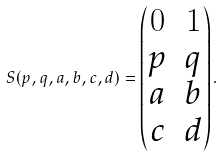Convert formula to latex. <formula><loc_0><loc_0><loc_500><loc_500>S ( p , q , a , b , c , d ) = \begin{pmatrix} 0 & 1 \\ p & q \\ a & b \\ c & d \end{pmatrix} .</formula> 